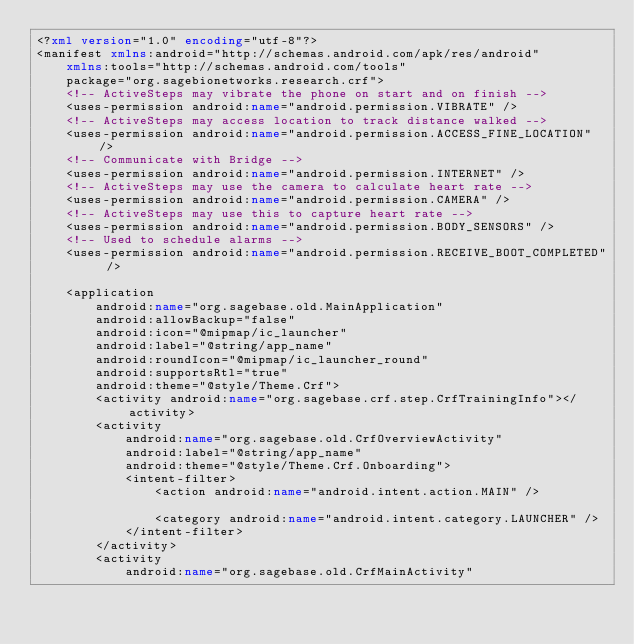<code> <loc_0><loc_0><loc_500><loc_500><_XML_><?xml version="1.0" encoding="utf-8"?>
<manifest xmlns:android="http://schemas.android.com/apk/res/android"
    xmlns:tools="http://schemas.android.com/tools"
    package="org.sagebionetworks.research.crf">
    <!-- ActiveSteps may vibrate the phone on start and on finish -->
    <uses-permission android:name="android.permission.VIBRATE" />
    <!-- ActiveSteps may access location to track distance walked -->
    <uses-permission android:name="android.permission.ACCESS_FINE_LOCATION" />
    <!-- Communicate with Bridge -->
    <uses-permission android:name="android.permission.INTERNET" />
    <!-- ActiveSteps may use the camera to calculate heart rate -->
    <uses-permission android:name="android.permission.CAMERA" />
    <!-- ActiveSteps may use this to capture heart rate -->
    <uses-permission android:name="android.permission.BODY_SENSORS" />
    <!-- Used to schedule alarms -->
    <uses-permission android:name="android.permission.RECEIVE_BOOT_COMPLETED" />

    <application
        android:name="org.sagebase.old.MainApplication"
        android:allowBackup="false"
        android:icon="@mipmap/ic_launcher"
        android:label="@string/app_name"
        android:roundIcon="@mipmap/ic_launcher_round"
        android:supportsRtl="true"
        android:theme="@style/Theme.Crf">
        <activity android:name="org.sagebase.crf.step.CrfTrainingInfo"></activity>
        <activity
            android:name="org.sagebase.old.CrfOverviewActivity"
            android:label="@string/app_name"
            android:theme="@style/Theme.Crf.Onboarding">
            <intent-filter>
                <action android:name="android.intent.action.MAIN" />

                <category android:name="android.intent.category.LAUNCHER" />
            </intent-filter>
        </activity>
        <activity
            android:name="org.sagebase.old.CrfMainActivity"</code> 